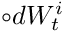<formula> <loc_0><loc_0><loc_500><loc_500>\circ d W _ { t } ^ { i }</formula> 